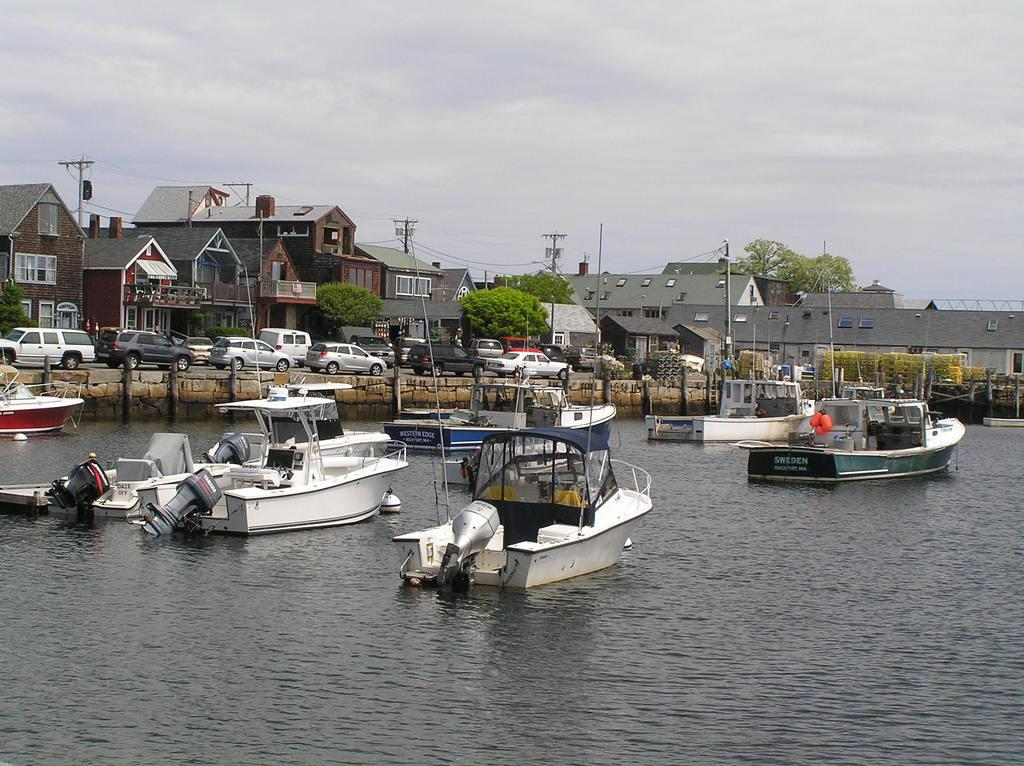What can be seen in the lake in the image? There are boats in the lake. What is located on the land in the image? There are buildings on the land. What type of vehicles are in front of the buildings? There are cars in front of the buildings. What is visible in the background of the image? The sky is visible in the image. What can be observed in the sky? Clouds are present in the sky. Where is the lift located in the image? There is no lift present in the image. What type of thread is being used to sew the hall in the image? There is no hall or sewing activity present in the image. 